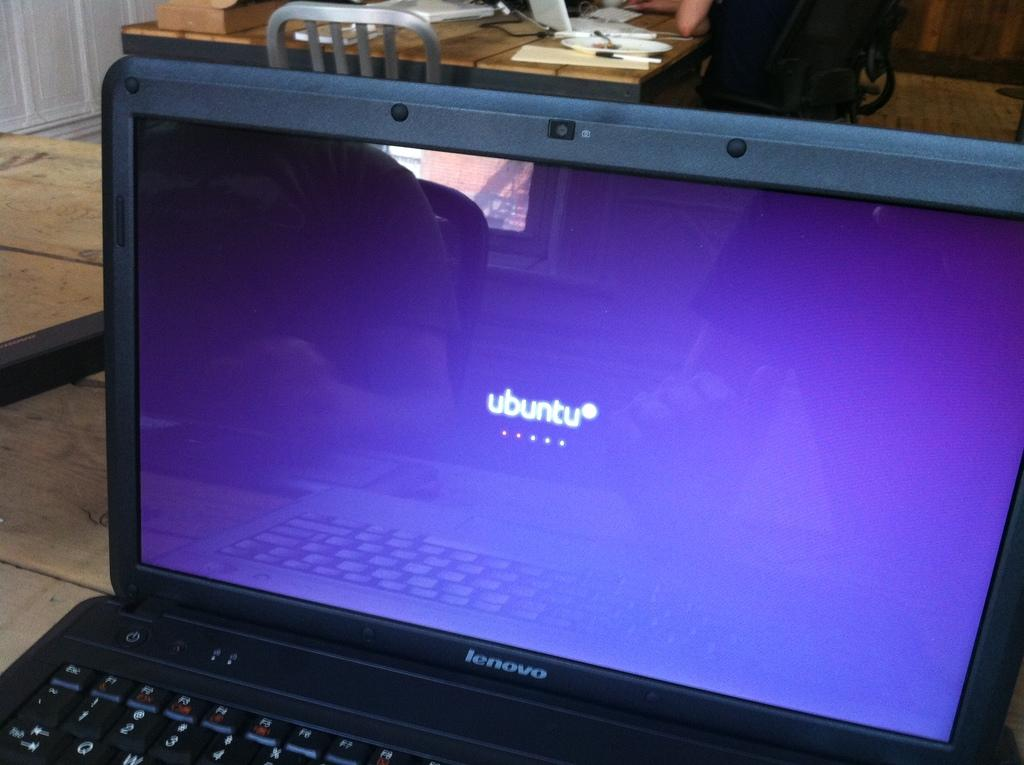What electronic device is visible in the image? There is a laptop in the image. What type of furniture can be seen in the background of the image? There is a table and a chair in the background of the image. What is on the table in the background? Papers are present on the table in the background. What type of boat is visible in the image? There is no boat present in the image. Where is the hospital located in the image? There is no hospital present in the image. 